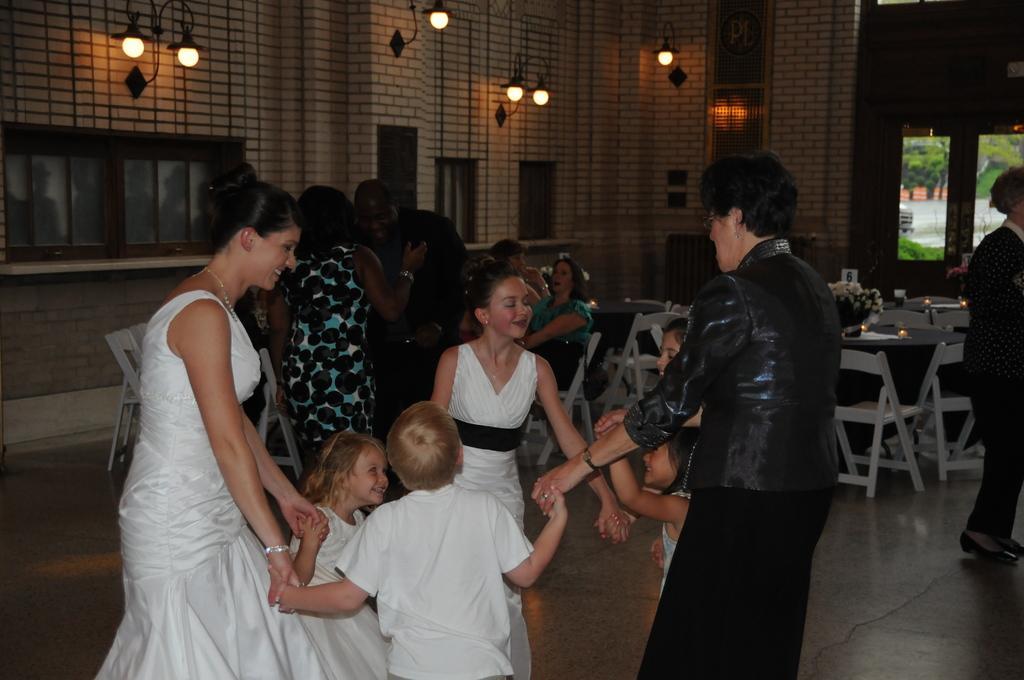Can you describe this image briefly? In the foreground of this image, there are two women, four girls and a boy are holding hands together and standing on the floor. In the background, there are tables, chairs, flower vase, few persons standing and few are sitting, wall, lights, windows and a door. 